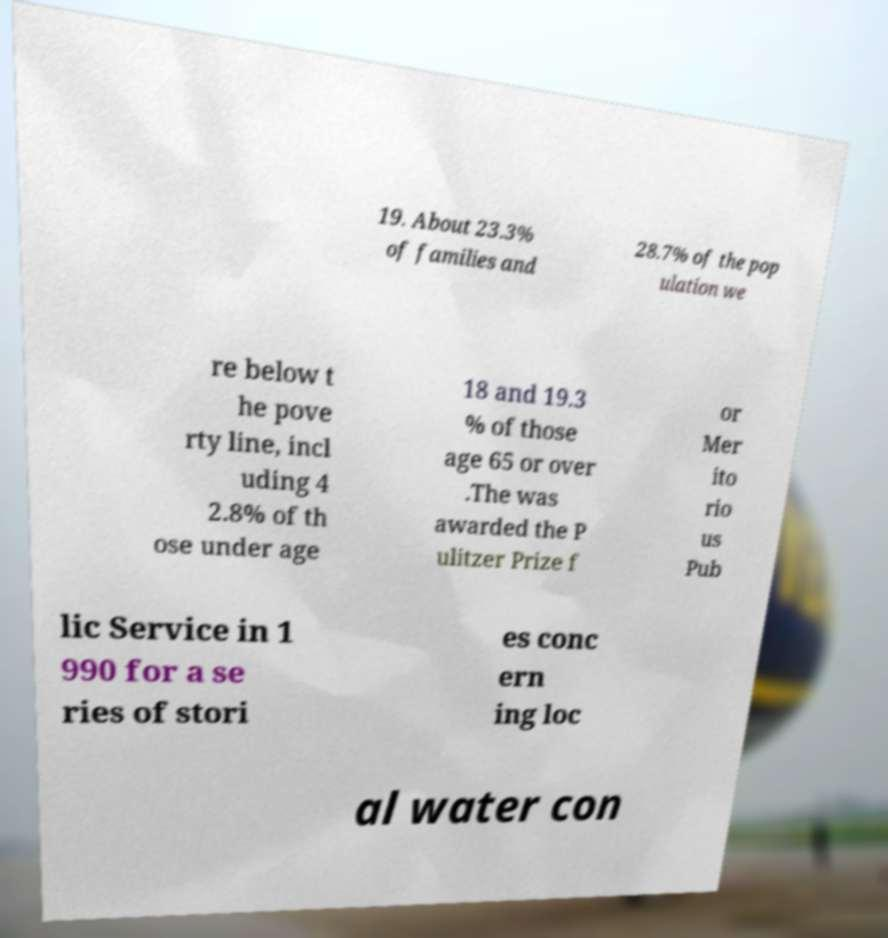Please read and relay the text visible in this image. What does it say? 19. About 23.3% of families and 28.7% of the pop ulation we re below t he pove rty line, incl uding 4 2.8% of th ose under age 18 and 19.3 % of those age 65 or over .The was awarded the P ulitzer Prize f or Mer ito rio us Pub lic Service in 1 990 for a se ries of stori es conc ern ing loc al water con 